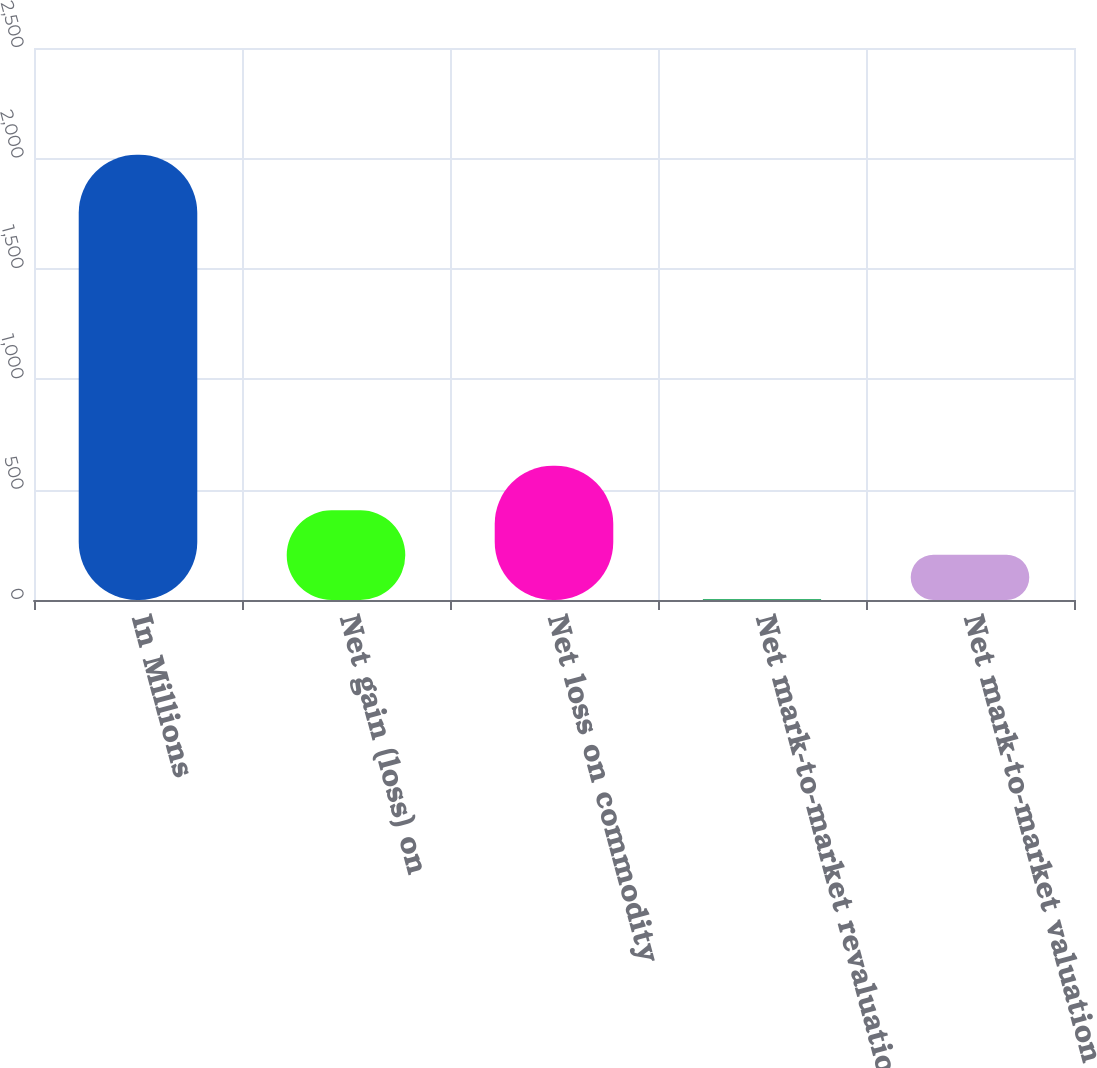Convert chart. <chart><loc_0><loc_0><loc_500><loc_500><bar_chart><fcel>In Millions<fcel>Net gain (loss) on<fcel>Net loss on commodity<fcel>Net mark-to-market revaluation<fcel>Net mark-to-market valuation<nl><fcel>2016<fcel>406.4<fcel>607.6<fcel>4<fcel>205.2<nl></chart> 